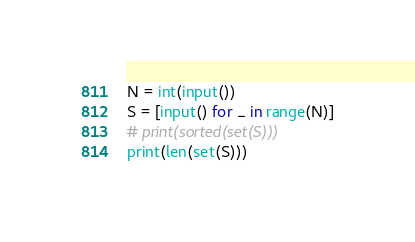Convert code to text. <code><loc_0><loc_0><loc_500><loc_500><_Python_>N = int(input())
S = [input() for _ in range(N)]
# print(sorted(set(S)))
print(len(set(S)))</code> 